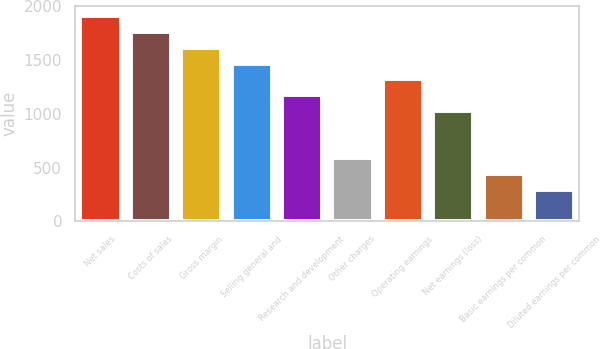<chart> <loc_0><loc_0><loc_500><loc_500><bar_chart><fcel>Net sales<fcel>Costs of sales<fcel>Gross margin<fcel>Selling general and<fcel>Research and development<fcel>Other charges<fcel>Operating earnings<fcel>Net earnings (loss)<fcel>Basic earnings per common<fcel>Diluted earnings per common<nl><fcel>1908.27<fcel>1761.52<fcel>1614.77<fcel>1468.02<fcel>1174.52<fcel>587.52<fcel>1321.27<fcel>1027.77<fcel>440.77<fcel>294.02<nl></chart> 